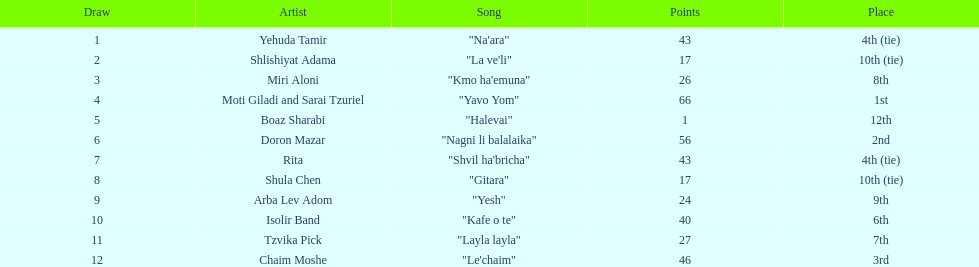Can you identify the song that comes immediately before "yesh"? "Gitara". I'm looking to parse the entire table for insights. Could you assist me with that? {'header': ['Draw', 'Artist', 'Song', 'Points', 'Place'], 'rows': [['1', 'Yehuda Tamir', '"Na\'ara"', '43', '4th (tie)'], ['2', 'Shlishiyat Adama', '"La ve\'li"', '17', '10th (tie)'], ['3', 'Miri Aloni', '"Kmo ha\'emuna"', '26', '8th'], ['4', 'Moti Giladi and Sarai Tzuriel', '"Yavo Yom"', '66', '1st'], ['5', 'Boaz Sharabi', '"Halevai"', '1', '12th'], ['6', 'Doron Mazar', '"Nagni li balalaika"', '56', '2nd'], ['7', 'Rita', '"Shvil ha\'bricha"', '43', '4th (tie)'], ['8', 'Shula Chen', '"Gitara"', '17', '10th (tie)'], ['9', 'Arba Lev Adom', '"Yesh"', '24', '9th'], ['10', 'Isolir Band', '"Kafe o te"', '40', '6th'], ['11', 'Tzvika Pick', '"Layla layla"', '27', '7th'], ['12', 'Chaim Moshe', '"Le\'chaim"', '46', '3rd']]} 